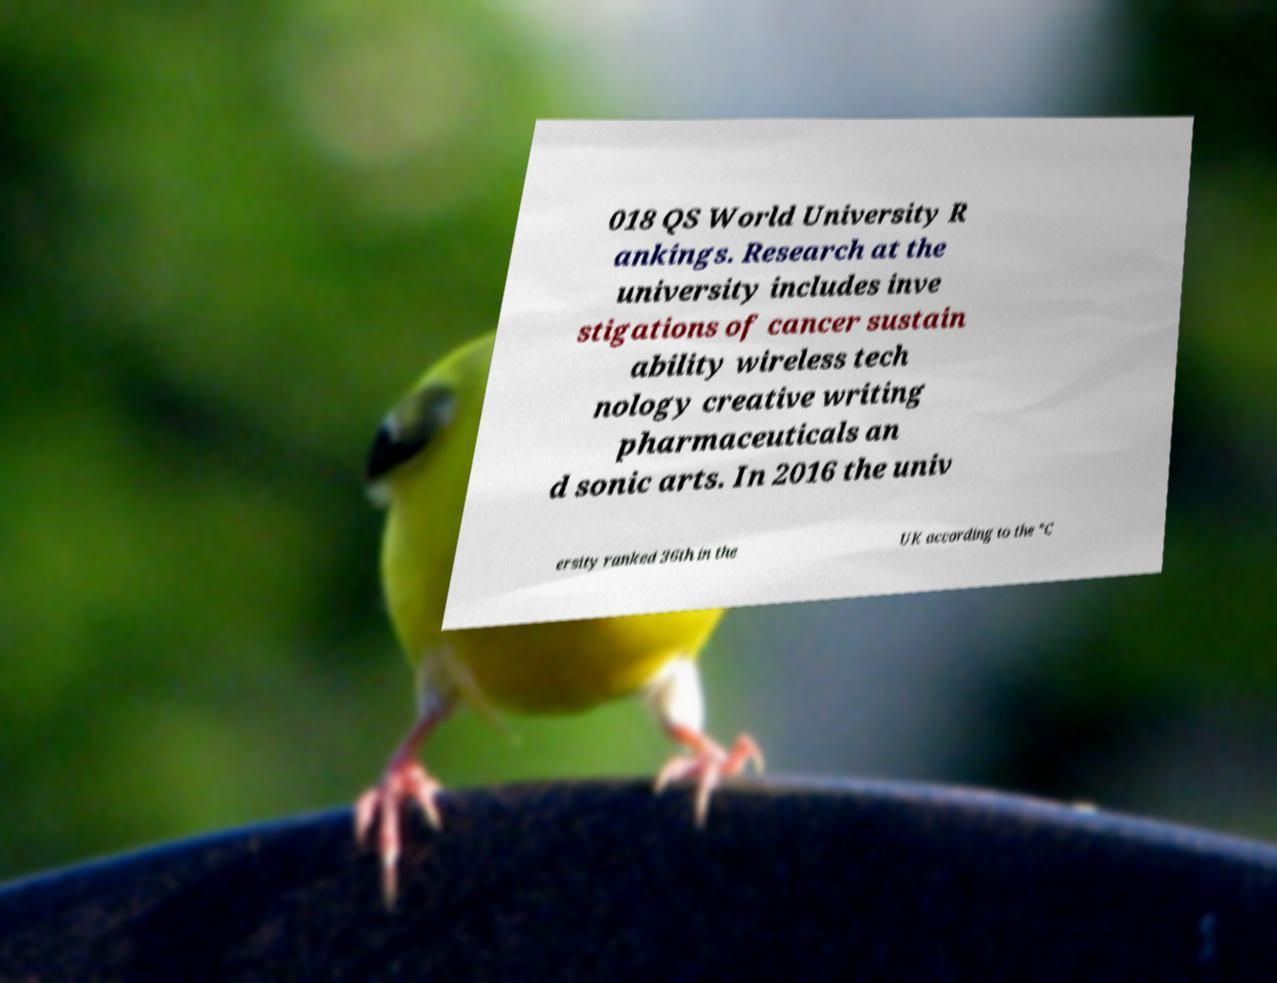Please identify and transcribe the text found in this image. 018 QS World University R ankings. Research at the university includes inve stigations of cancer sustain ability wireless tech nology creative writing pharmaceuticals an d sonic arts. In 2016 the univ ersity ranked 36th in the UK according to the "C 